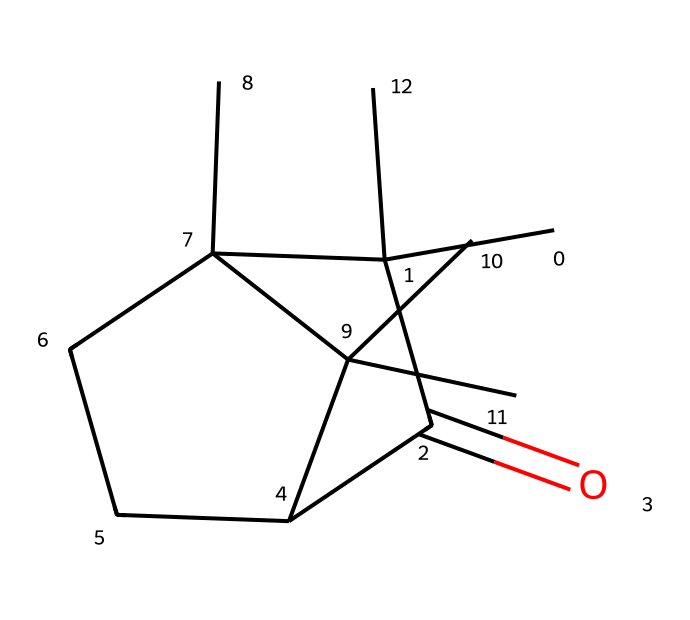How many carbon atoms are in camphor? By examining the SMILES representation, we can identify the number of 'C' characters which represent carbon atoms. There are a total of 15 carbon atoms in the structure.
Answer: 15 What functional group is present in camphor? Looking at the structure, there is a carbonyl group (C=O) present in the molecule, indicating it is a ketone. The presence of a C=O connection signifies the functional group.
Answer: ketone How many rings are in the camphor structure? Analyzing the rings in the chemical structure, there are two distinct cyclic portions indicated by the cyclo- components in the SMILES notation, revealing the presence of two interlinked rings.
Answer: 2 What is the molecular formula of camphor? By summing up the number of each type of atom from the SMILES, we can derive the molecular formula as C15H24O, which indicates the overall composition of the molecule.
Answer: C15H24O Is camphor a saturated or unsaturated compound? Observing the structure, the presence of no double or triple bonds other than the carbonyl indicates that all carbon-carbon bonds are single, classifying camphor as a saturated compound.
Answer: saturated Which part of the camphor structure indicates its cyclic nature? The presence of the cyclic components (represented by the 'C' atoms grouped in cycles) relates directly to its construction as a cyclic compound, as it forms closed loop structures.
Answer: cyclic How many hydrogen atoms are attached to the carbons in camphor? By applying the tetravalence rule of carbon and considering each carbon's bonding, it can be determined through calculations that the total number of hydrogen atoms connected is 24.
Answer: 24 